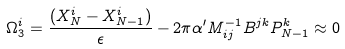Convert formula to latex. <formula><loc_0><loc_0><loc_500><loc_500>\Omega _ { 3 } ^ { i } = \frac { ( X _ { N } ^ { i } - X _ { N - 1 } ^ { i } ) } { \epsilon } - 2 \pi \alpha ^ { \prime } M _ { i j } ^ { - 1 } B ^ { j k } P _ { N - 1 } ^ { k } \approx 0</formula> 